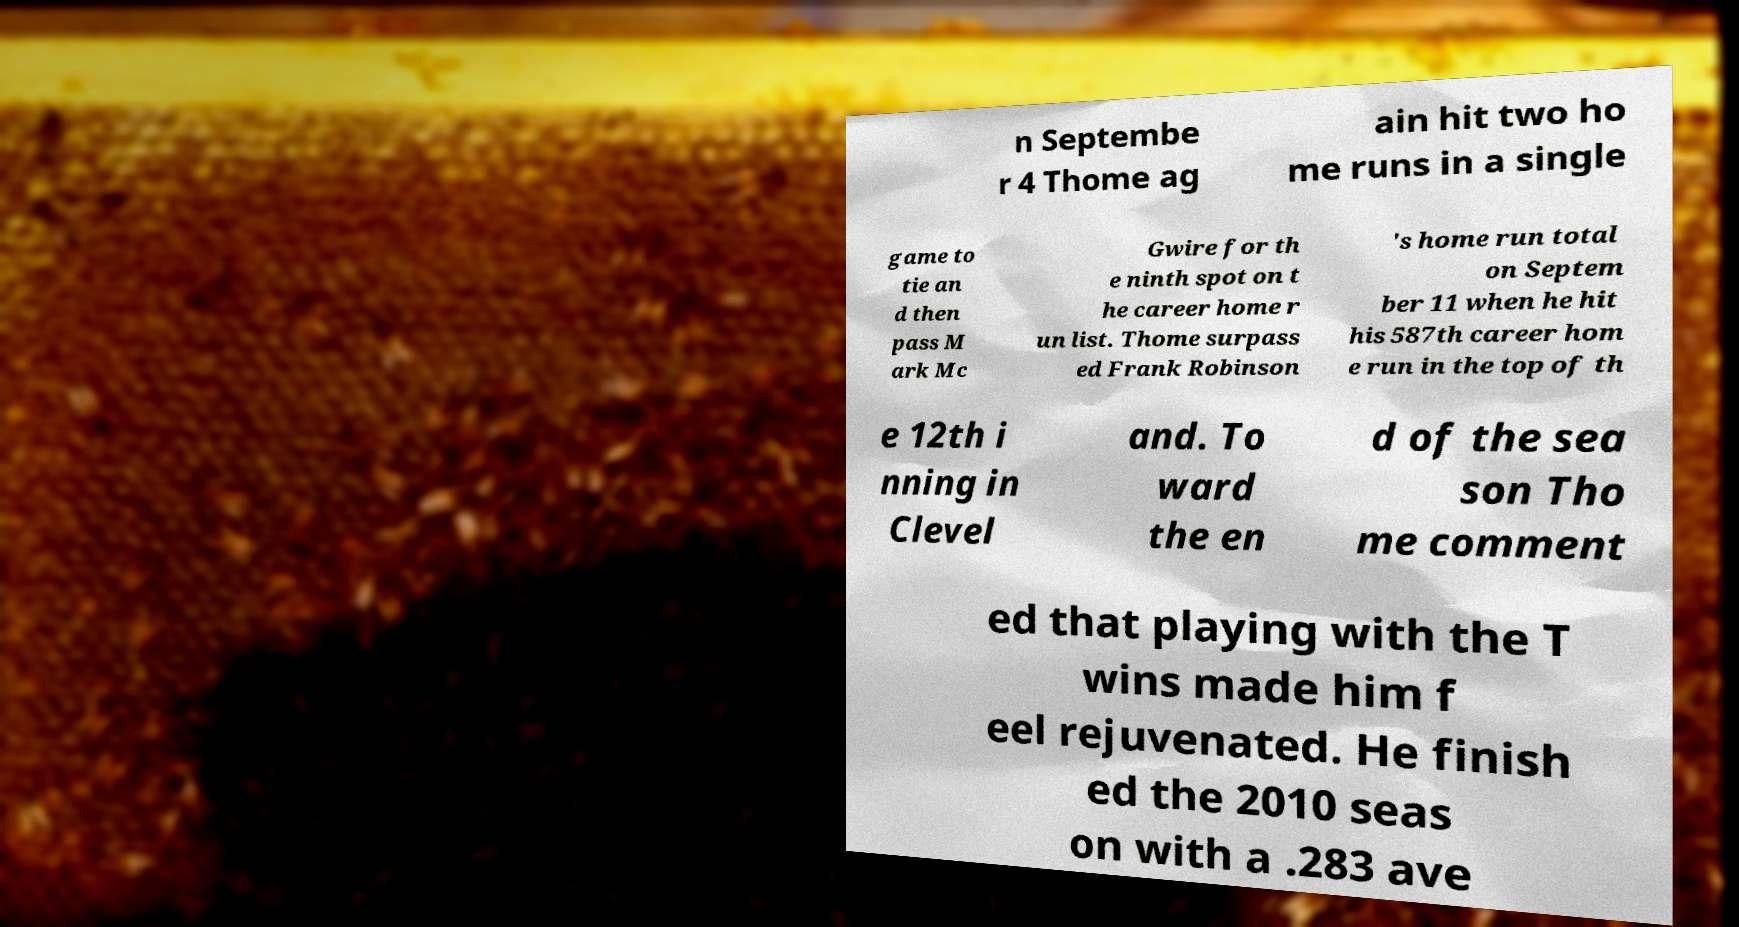Can you accurately transcribe the text from the provided image for me? n Septembe r 4 Thome ag ain hit two ho me runs in a single game to tie an d then pass M ark Mc Gwire for th e ninth spot on t he career home r un list. Thome surpass ed Frank Robinson 's home run total on Septem ber 11 when he hit his 587th career hom e run in the top of th e 12th i nning in Clevel and. To ward the en d of the sea son Tho me comment ed that playing with the T wins made him f eel rejuvenated. He finish ed the 2010 seas on with a .283 ave 